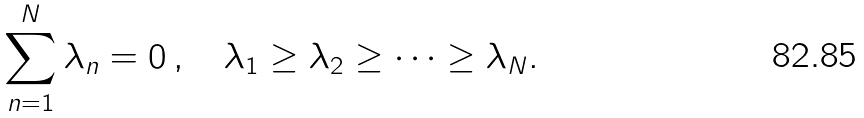<formula> <loc_0><loc_0><loc_500><loc_500>\sum _ { n = 1 } ^ { N } \lambda _ { n } = 0 \, , \quad \lambda _ { 1 } \geq \lambda _ { 2 } \geq \dots \geq \lambda _ { N } .</formula> 